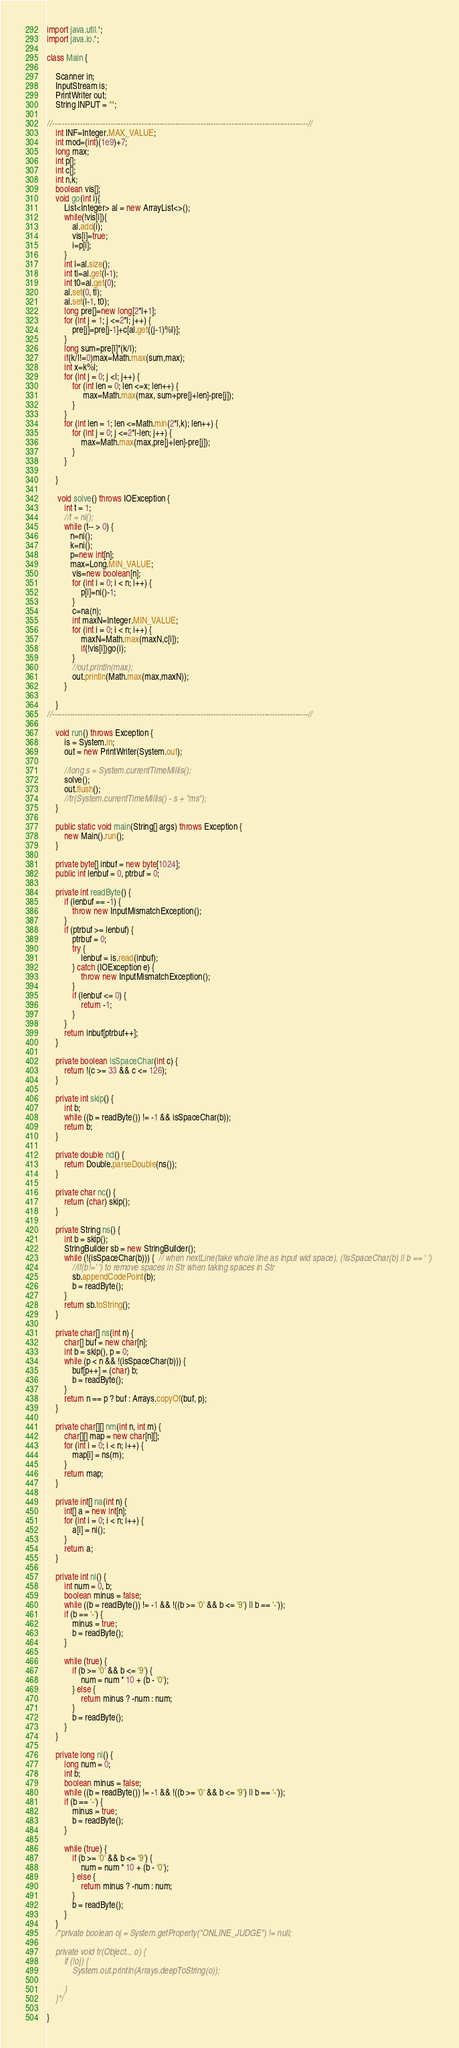Convert code to text. <code><loc_0><loc_0><loc_500><loc_500><_Java_>import java.util.*;
import java.io.*;

class Main {

    Scanner in;
    InputStream is;
    PrintWriter out;
    String INPUT = "";
    
//----------------------------------------------------------------------------------------------------//
    int INF=Integer.MAX_VALUE;
    int mod=(int)(1e9)+7;
    long max;
    int p[];
    int c[];
    int n,k;
    boolean vis[];
    void go(int i){
        List<Integer> al = new ArrayList<>();
        while(!vis[i]){
            al.add(i);
            vis[i]=true;
            i=p[i];
        }
        int l=al.size();
        int tl=al.get(l-1);
        int t0=al.get(0);
        al.set(0, tl);
        al.set(l-1, t0);
        long pre[]=new long[2*l+1];
        for (int j = 1; j <=2*l; j++) {
            pre[j]=pre[j-1]+c[al.get((j-1)%l)];
        }
        long sum=pre[l]*(k/l);
        if(k/l!=0)max=Math.max(sum,max);
        int x=k%l;
        for (int j = 0; j <l; j++) {
            for (int len = 0; len <=x; len++) {
                 max=Math.max(max, sum+pre[j+len]-pre[j]);
            }
        }
        for (int len = 1; len <=Math.min(2*l,k); len++) {
            for (int j = 0; j <=2*l-len; j++) {
                max=Math.max(max,pre[j+len]-pre[j]);
            }
        }
        
    }
    
     void solve() throws IOException {
        int t = 1;
        //t = ni();
        while (t-- > 0) {
           n=ni();
           k=ni();
           p=new int[n];
           max=Long.MIN_VALUE;
            vis=new boolean[n];
            for (int i = 0; i < n; i++) {
                p[i]=ni()-1;
            }
            c=na(n);
            int maxN=Integer.MIN_VALUE;
            for (int i = 0; i < n; i++) {
                maxN=Math.max(maxN,c[i]);
                if(!vis[i])go(i);
            }
            //out.println(max);
            out.println(Math.max(max,maxN));
        }

    }
//----------------------------------------------------------------------------------------------------//

    void run() throws Exception {
        is = System.in;
        out = new PrintWriter(System.out);

        //long s = System.currentTimeMillis();
        solve();
        out.flush();
        //tr(System.currentTimeMillis() - s + "ms");
    }

    public static void main(String[] args) throws Exception {
        new Main().run();
    }

    private byte[] inbuf = new byte[1024];
    public int lenbuf = 0, ptrbuf = 0;

    private int readByte() {
        if (lenbuf == -1) {
            throw new InputMismatchException();
        }
        if (ptrbuf >= lenbuf) {
            ptrbuf = 0;
            try {
                lenbuf = is.read(inbuf);
            } catch (IOException e) {
                throw new InputMismatchException();
            }
            if (lenbuf <= 0) {
                return -1;
            }
        }
        return inbuf[ptrbuf++];
    }

    private boolean isSpaceChar(int c) {
        return !(c >= 33 && c <= 126);
    }

    private int skip() {
        int b;
        while ((b = readByte()) != -1 && isSpaceChar(b));
        return b;
    }

    private double nd() {
        return Double.parseDouble(ns());
    }

    private char nc() {
        return (char) skip();
    }

    private String ns() {
        int b = skip();
        StringBuilder sb = new StringBuilder();
        while (!(isSpaceChar(b))) {  // when nextLine(take whole line as input wid space), (!isSpaceChar(b) || b == ' ') 
            //if(b!=' ') to remove spaces in Str when taking spaces in Str
            sb.appendCodePoint(b);
            b = readByte();
        }
        return sb.toString();
    }

    private char[] ns(int n) {
        char[] buf = new char[n];
        int b = skip(), p = 0;
        while (p < n && !(isSpaceChar(b))) {
            buf[p++] = (char) b;
            b = readByte();
        }
        return n == p ? buf : Arrays.copyOf(buf, p);
    }

    private char[][] nm(int n, int m) {
        char[][] map = new char[n][];
        for (int i = 0; i < n; i++) {
            map[i] = ns(m);
        }
        return map;
    }

    private int[] na(int n) {
        int[] a = new int[n];
        for (int i = 0; i < n; i++) {
            a[i] = ni();
        }
        return a;
    }

    private int ni() {
        int num = 0, b;
        boolean minus = false;
        while ((b = readByte()) != -1 && !((b >= '0' && b <= '9') || b == '-'));
        if (b == '-') {
            minus = true;
            b = readByte();
        }

        while (true) {
            if (b >= '0' && b <= '9') {
                num = num * 10 + (b - '0');
            } else {
                return minus ? -num : num;
            }
            b = readByte();
        }
    }

    private long nl() {
        long num = 0;
        int b;
        boolean minus = false;
        while ((b = readByte()) != -1 && !((b >= '0' && b <= '9') || b == '-'));
        if (b == '-') {
            minus = true;
            b = readByte();
        }

        while (true) {
            if (b >= '0' && b <= '9') {
                num = num * 10 + (b - '0');
            } else {
                return minus ? -num : num;
            }
            b = readByte();
        }
    }
    /*private boolean oj = System.getProperty("ONLINE_JUDGE") != null;
    
    private void tr(Object... o) {
        if (!oj) {
            System.out.println(Arrays.deepToString(o));
            
        }
    }*/

}
</code> 